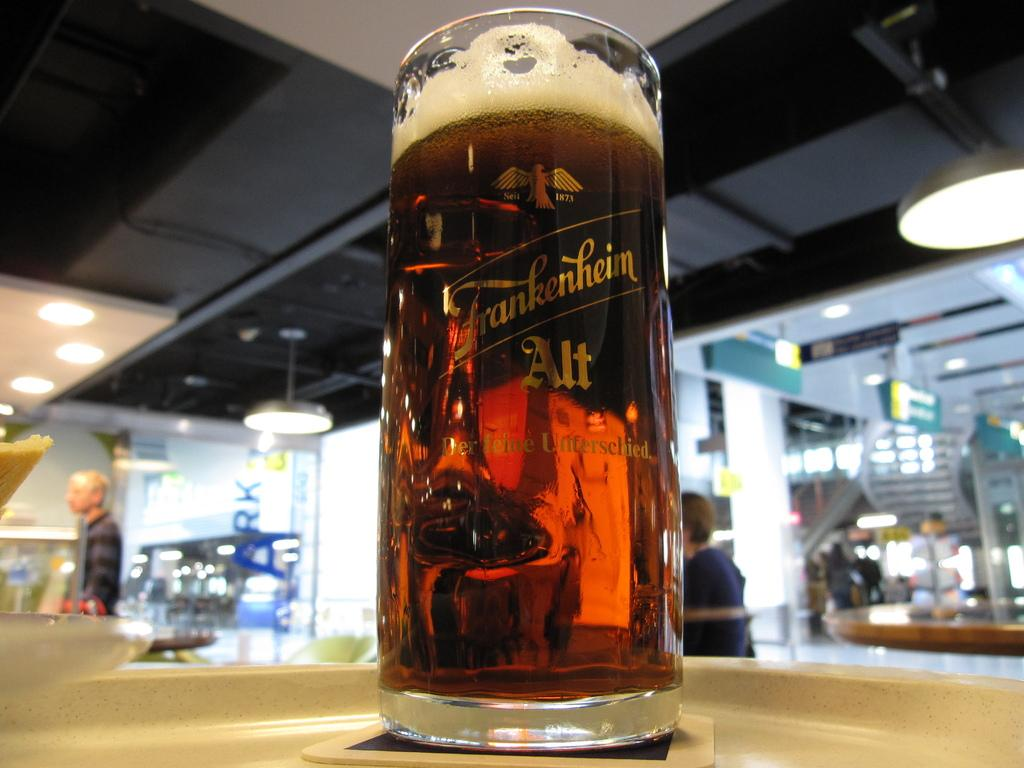<image>
Summarize the visual content of the image. Frankenheim glass that contains beer on a table 